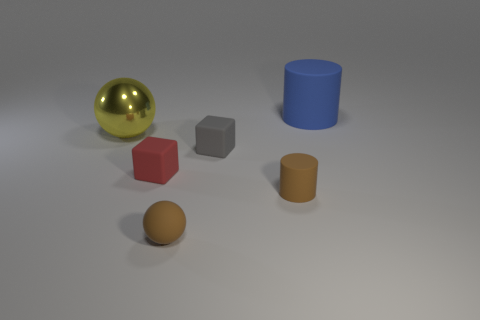Add 2 big metal balls. How many objects exist? 8 Subtract all cubes. How many objects are left? 4 Add 2 gray rubber blocks. How many gray rubber blocks are left? 3 Add 1 large red cylinders. How many large red cylinders exist? 1 Subtract 0 gray spheres. How many objects are left? 6 Subtract all yellow metal spheres. Subtract all brown matte things. How many objects are left? 3 